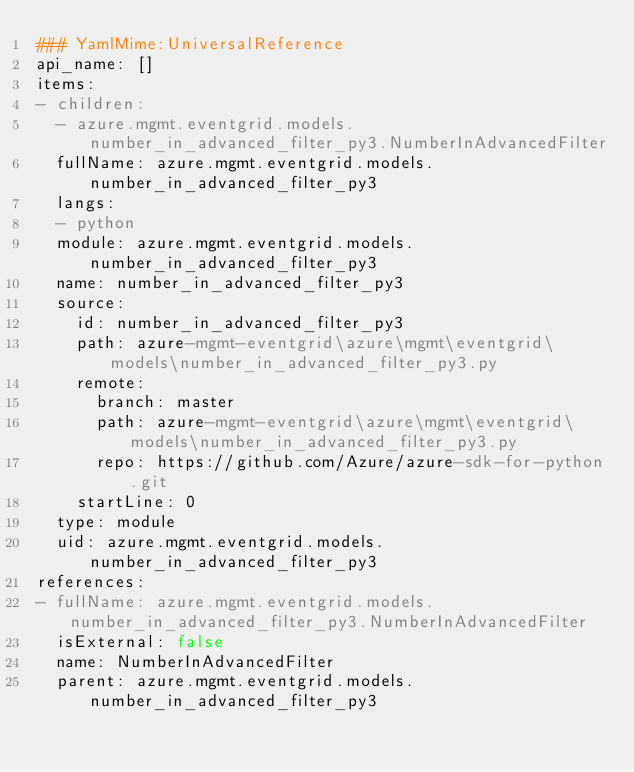<code> <loc_0><loc_0><loc_500><loc_500><_YAML_>### YamlMime:UniversalReference
api_name: []
items:
- children:
  - azure.mgmt.eventgrid.models.number_in_advanced_filter_py3.NumberInAdvancedFilter
  fullName: azure.mgmt.eventgrid.models.number_in_advanced_filter_py3
  langs:
  - python
  module: azure.mgmt.eventgrid.models.number_in_advanced_filter_py3
  name: number_in_advanced_filter_py3
  source:
    id: number_in_advanced_filter_py3
    path: azure-mgmt-eventgrid\azure\mgmt\eventgrid\models\number_in_advanced_filter_py3.py
    remote:
      branch: master
      path: azure-mgmt-eventgrid\azure\mgmt\eventgrid\models\number_in_advanced_filter_py3.py
      repo: https://github.com/Azure/azure-sdk-for-python.git
    startLine: 0
  type: module
  uid: azure.mgmt.eventgrid.models.number_in_advanced_filter_py3
references:
- fullName: azure.mgmt.eventgrid.models.number_in_advanced_filter_py3.NumberInAdvancedFilter
  isExternal: false
  name: NumberInAdvancedFilter
  parent: azure.mgmt.eventgrid.models.number_in_advanced_filter_py3</code> 